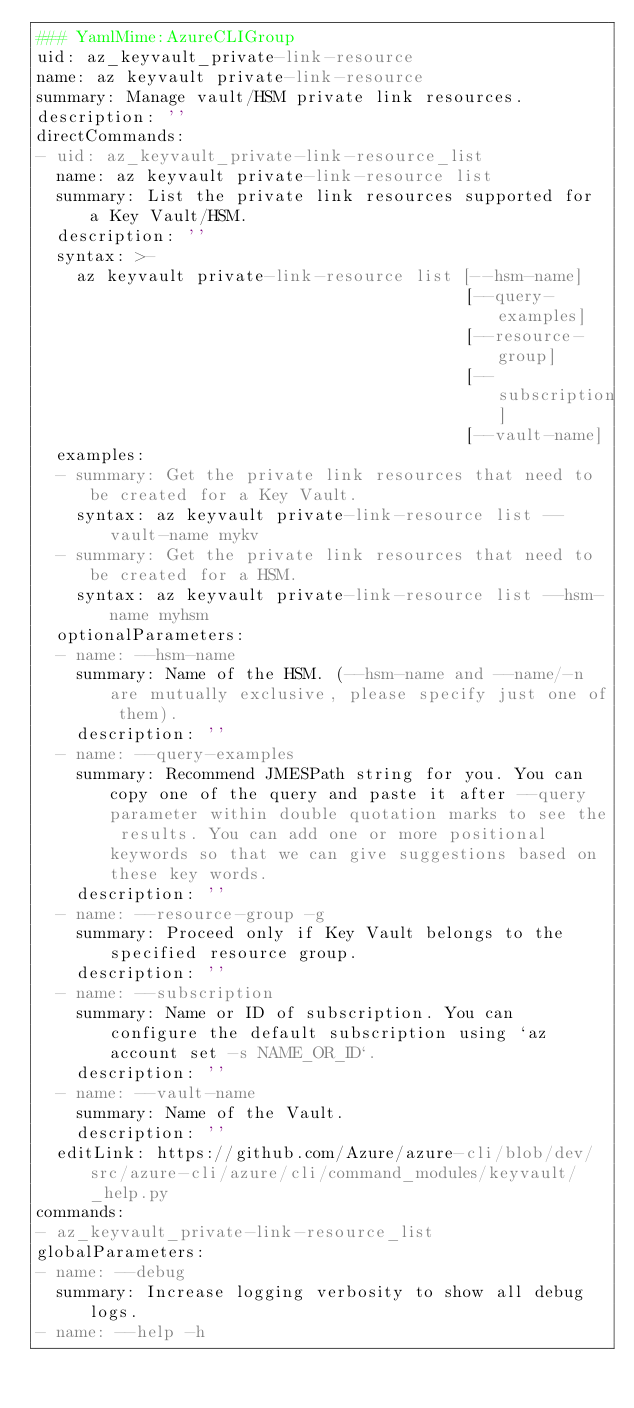Convert code to text. <code><loc_0><loc_0><loc_500><loc_500><_YAML_>### YamlMime:AzureCLIGroup
uid: az_keyvault_private-link-resource
name: az keyvault private-link-resource
summary: Manage vault/HSM private link resources.
description: ''
directCommands:
- uid: az_keyvault_private-link-resource_list
  name: az keyvault private-link-resource list
  summary: List the private link resources supported for a Key Vault/HSM.
  description: ''
  syntax: >-
    az keyvault private-link-resource list [--hsm-name]
                                           [--query-examples]
                                           [--resource-group]
                                           [--subscription]
                                           [--vault-name]
  examples:
  - summary: Get the private link resources that need to be created for a Key Vault.
    syntax: az keyvault private-link-resource list --vault-name mykv
  - summary: Get the private link resources that need to be created for a HSM.
    syntax: az keyvault private-link-resource list --hsm-name myhsm
  optionalParameters:
  - name: --hsm-name
    summary: Name of the HSM. (--hsm-name and --name/-n are mutually exclusive, please specify just one of them).
    description: ''
  - name: --query-examples
    summary: Recommend JMESPath string for you. You can copy one of the query and paste it after --query parameter within double quotation marks to see the results. You can add one or more positional keywords so that we can give suggestions based on these key words.
    description: ''
  - name: --resource-group -g
    summary: Proceed only if Key Vault belongs to the specified resource group.
    description: ''
  - name: --subscription
    summary: Name or ID of subscription. You can configure the default subscription using `az account set -s NAME_OR_ID`.
    description: ''
  - name: --vault-name
    summary: Name of the Vault.
    description: ''
  editLink: https://github.com/Azure/azure-cli/blob/dev/src/azure-cli/azure/cli/command_modules/keyvault/_help.py
commands:
- az_keyvault_private-link-resource_list
globalParameters:
- name: --debug
  summary: Increase logging verbosity to show all debug logs.
- name: --help -h</code> 